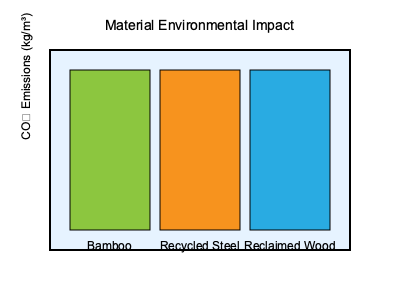In a sustainable architecture project inspired by Maya Bird-Murphy's principles, you're tasked with estimating the total CO₂ emissions for the materials used. The project requires 50 m³ of bamboo, 30 m³ of recycled steel, and 40 m³ of reclaimed wood. Given the graph showing relative CO₂ emissions per cubic meter for each material, calculate the total CO₂ emissions for the project. Assume the height of each bar represents the following emissions: Bamboo - 20 kg/m³, Recycled Steel - 120 kg/m³, Reclaimed Wood - 40 kg/m³. To calculate the total CO₂ emissions for the project, we need to follow these steps:

1. Identify the CO₂ emissions per cubic meter for each material:
   - Bamboo: 20 kg/m³
   - Recycled Steel: 120 kg/m³
   - Reclaimed Wood: 40 kg/m³

2. Calculate the CO₂ emissions for each material based on the required volume:
   - Bamboo: $50 \text{ m³} \times 20 \text{ kg/m³} = 1000 \text{ kg}$
   - Recycled Steel: $30 \text{ m³} \times 120 \text{ kg/m³} = 3600 \text{ kg}$
   - Reclaimed Wood: $40 \text{ m³} \times 40 \text{ kg/m³} = 1600 \text{ kg}$

3. Sum up the total CO₂ emissions:
   $\text{Total CO₂ emissions} = 1000 \text{ kg} + 3600 \text{ kg} + 1600 \text{ kg} = 6200 \text{ kg}$

Therefore, the total CO₂ emissions for the materials used in the project is 6200 kg.
Answer: 6200 kg 